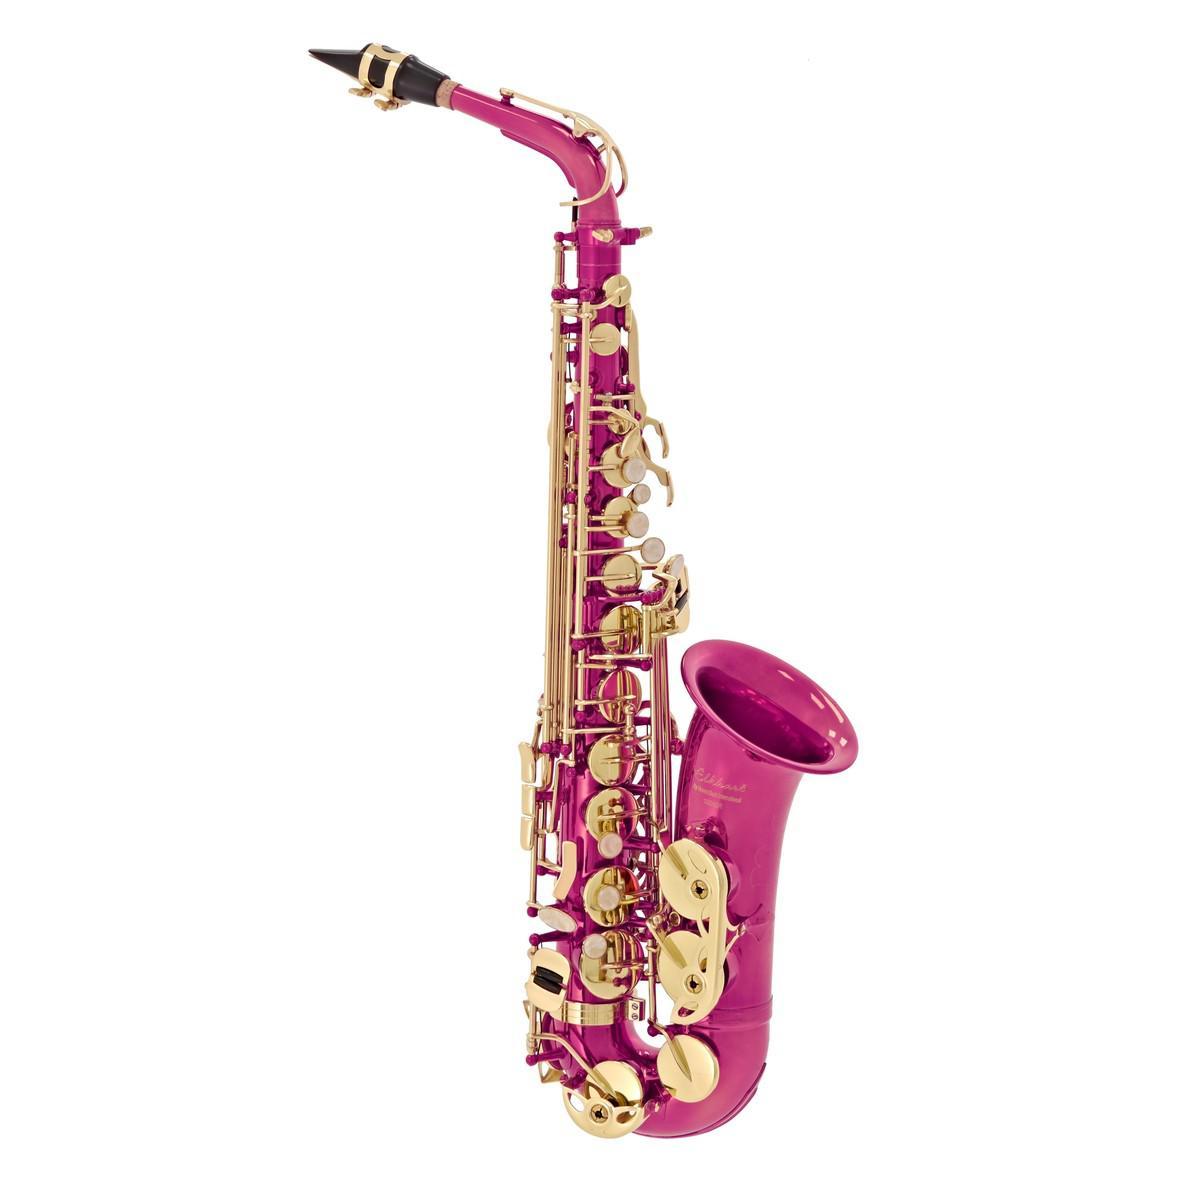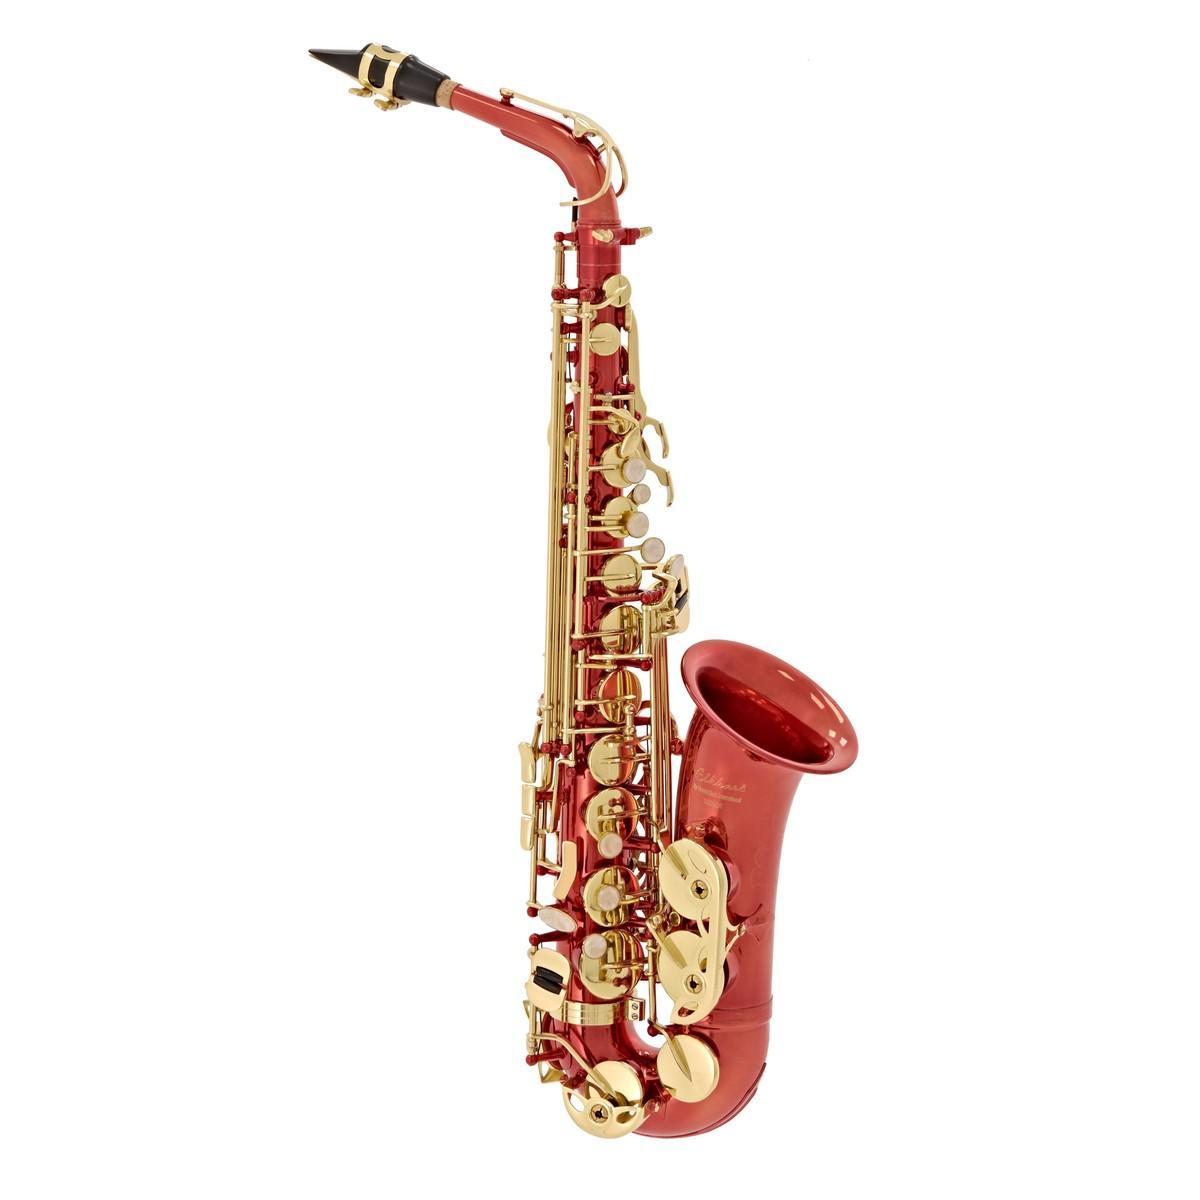The first image is the image on the left, the second image is the image on the right. Analyze the images presented: Is the assertion "One saxophone has a traditional metallic colored body, and the other has a body colored some shade of pink." valid? Answer yes or no. No. The first image is the image on the left, the second image is the image on the right. Assess this claim about the two images: "Exactly two saxophones are the same size and positioned at the same angle, but are different colors.". Correct or not? Answer yes or no. Yes. 